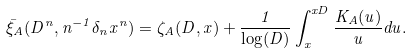<formula> <loc_0><loc_0><loc_500><loc_500>\bar { \xi } _ { A } ( D ^ { n } , n ^ { - 1 } \delta _ { n } x ^ { n } ) = \zeta _ { A } ( D , x ) + \frac { 1 } { \log ( D ) } \int _ { x } ^ { x D } \frac { K _ { A } ( u ) } { u } d u .</formula> 